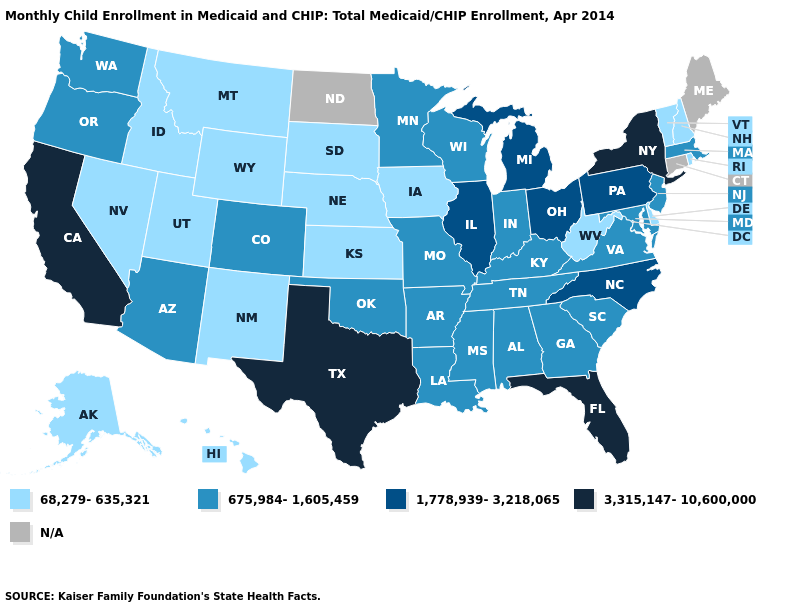Which states have the lowest value in the West?
Short answer required. Alaska, Hawaii, Idaho, Montana, Nevada, New Mexico, Utah, Wyoming. Does Utah have the highest value in the USA?
Concise answer only. No. What is the value of Missouri?
Keep it brief. 675,984-1,605,459. What is the value of Wisconsin?
Write a very short answer. 675,984-1,605,459. What is the value of Maine?
Short answer required. N/A. Does the map have missing data?
Answer briefly. Yes. Name the states that have a value in the range N/A?
Short answer required. Connecticut, Maine, North Dakota. Does the first symbol in the legend represent the smallest category?
Concise answer only. Yes. What is the value of Arizona?
Keep it brief. 675,984-1,605,459. What is the highest value in states that border California?
Concise answer only. 675,984-1,605,459. Name the states that have a value in the range N/A?
Keep it brief. Connecticut, Maine, North Dakota. What is the value of Missouri?
Answer briefly. 675,984-1,605,459. Name the states that have a value in the range 675,984-1,605,459?
Quick response, please. Alabama, Arizona, Arkansas, Colorado, Georgia, Indiana, Kentucky, Louisiana, Maryland, Massachusetts, Minnesota, Mississippi, Missouri, New Jersey, Oklahoma, Oregon, South Carolina, Tennessee, Virginia, Washington, Wisconsin. Does the map have missing data?
Short answer required. Yes. 